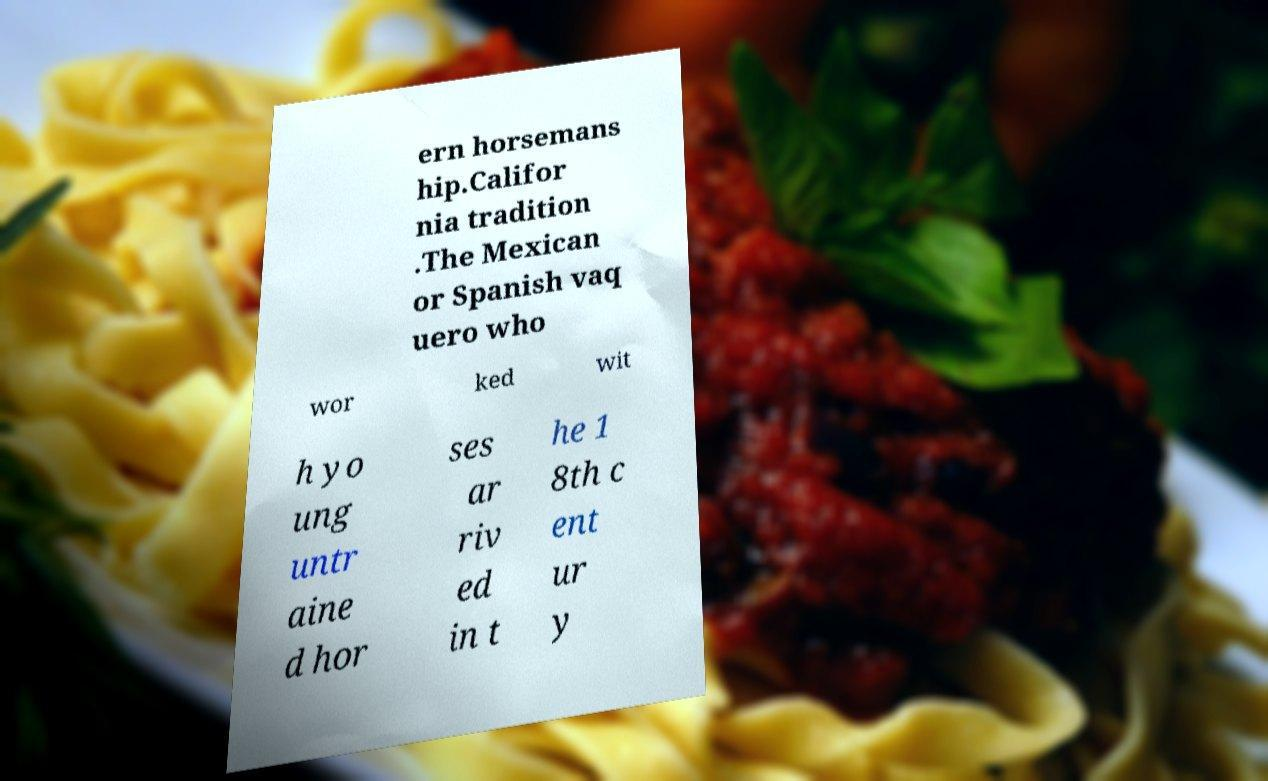I need the written content from this picture converted into text. Can you do that? ern horsemans hip.Califor nia tradition .The Mexican or Spanish vaq uero who wor ked wit h yo ung untr aine d hor ses ar riv ed in t he 1 8th c ent ur y 